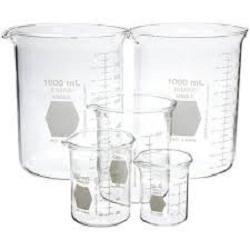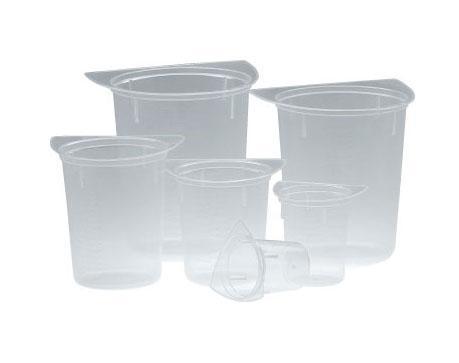The first image is the image on the left, the second image is the image on the right. For the images shown, is this caption "Exactly five beakers in one image and three in the other image are all empty and different sizes." true? Answer yes or no. No. The first image is the image on the left, the second image is the image on the right. Evaluate the accuracy of this statement regarding the images: "There are exactly 3 beakers in one of the images.". Is it true? Answer yes or no. No. 